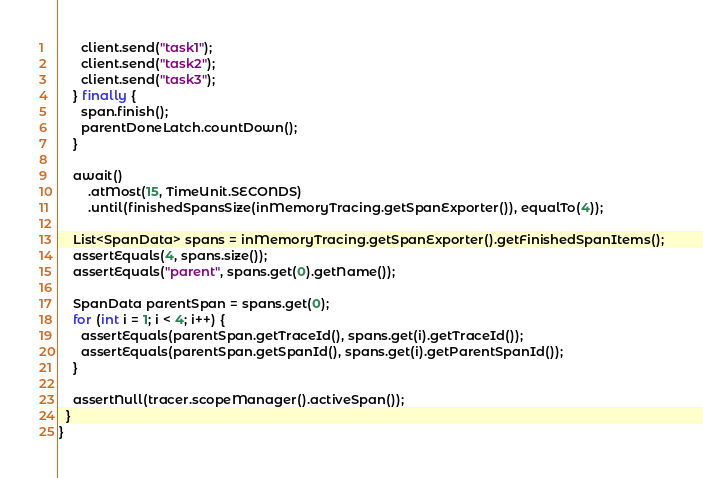Convert code to text. <code><loc_0><loc_0><loc_500><loc_500><_Java_>      client.send("task1");
      client.send("task2");
      client.send("task3");
    } finally {
      span.finish();
      parentDoneLatch.countDown();
    }

    await()
        .atMost(15, TimeUnit.SECONDS)
        .until(finishedSpansSize(inMemoryTracing.getSpanExporter()), equalTo(4));

    List<SpanData> spans = inMemoryTracing.getSpanExporter().getFinishedSpanItems();
    assertEquals(4, spans.size());
    assertEquals("parent", spans.get(0).getName());

    SpanData parentSpan = spans.get(0);
    for (int i = 1; i < 4; i++) {
      assertEquals(parentSpan.getTraceId(), spans.get(i).getTraceId());
      assertEquals(parentSpan.getSpanId(), spans.get(i).getParentSpanId());
    }

    assertNull(tracer.scopeManager().activeSpan());
  }
}
</code> 